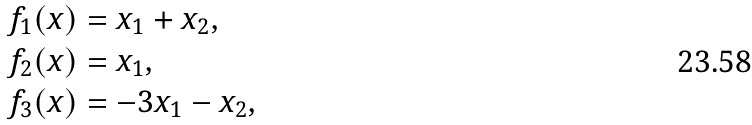Convert formula to latex. <formula><loc_0><loc_0><loc_500><loc_500>f _ { 1 } ( x ) & = x _ { 1 } + x _ { 2 } , \\ f _ { 2 } ( x ) & = x _ { 1 } , \\ f _ { 3 } ( x ) & = - 3 x _ { 1 } - x _ { 2 } ,</formula> 